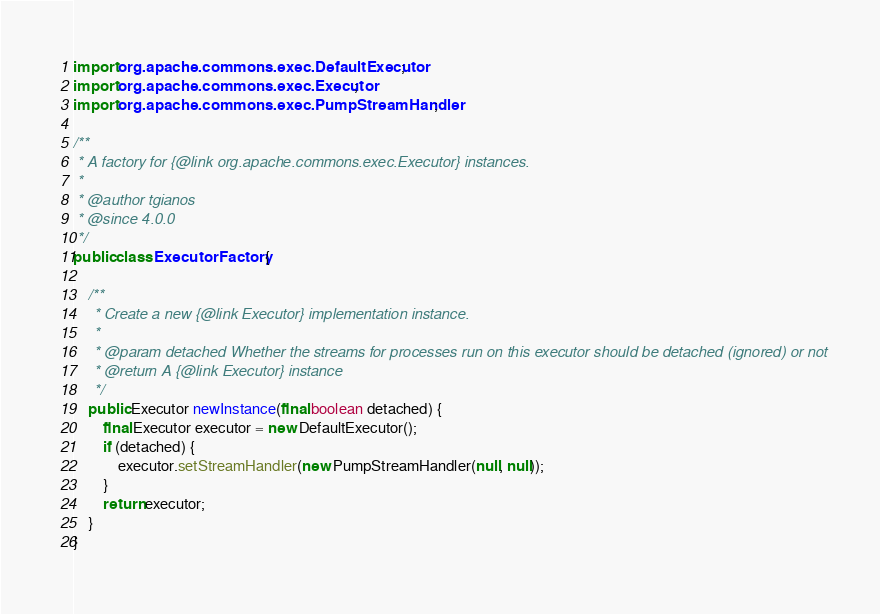<code> <loc_0><loc_0><loc_500><loc_500><_Java_>
import org.apache.commons.exec.DefaultExecutor;
import org.apache.commons.exec.Executor;
import org.apache.commons.exec.PumpStreamHandler;

/**
 * A factory for {@link org.apache.commons.exec.Executor} instances.
 *
 * @author tgianos
 * @since 4.0.0
 */
public class ExecutorFactory {

    /**
     * Create a new {@link Executor} implementation instance.
     *
     * @param detached Whether the streams for processes run on this executor should be detached (ignored) or not
     * @return A {@link Executor} instance
     */
    public Executor newInstance(final boolean detached) {
        final Executor executor = new DefaultExecutor();
        if (detached) {
            executor.setStreamHandler(new PumpStreamHandler(null, null));
        }
        return executor;
    }
}
</code> 